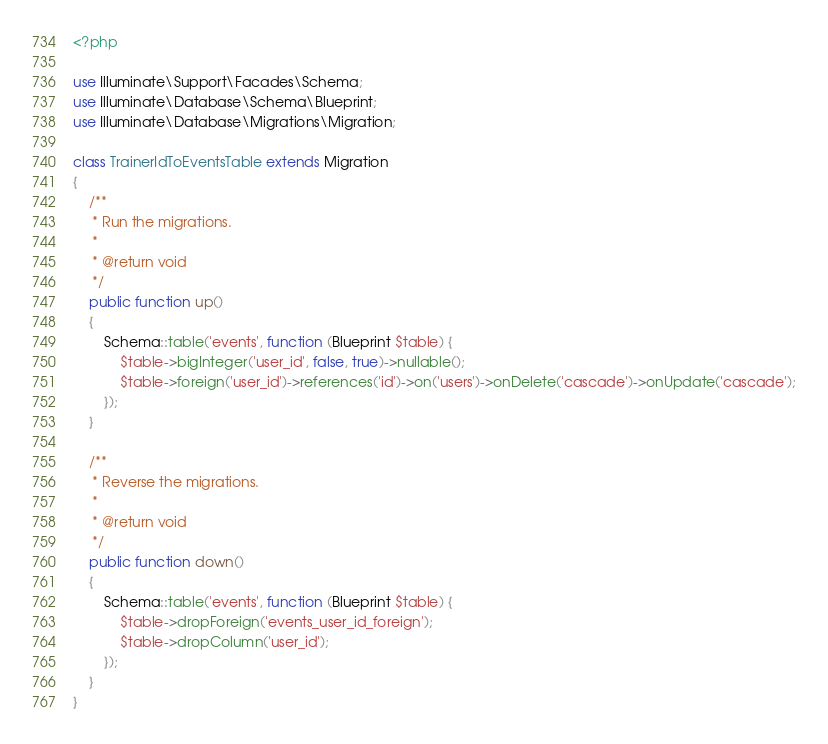Convert code to text. <code><loc_0><loc_0><loc_500><loc_500><_PHP_><?php

use Illuminate\Support\Facades\Schema;
use Illuminate\Database\Schema\Blueprint;
use Illuminate\Database\Migrations\Migration;

class TrainerIdToEventsTable extends Migration
{
    /**
     * Run the migrations.
     *
     * @return void
     */
    public function up()
    {
        Schema::table('events', function (Blueprint $table) {
            $table->bigInteger('user_id', false, true)->nullable();
            $table->foreign('user_id')->references('id')->on('users')->onDelete('cascade')->onUpdate('cascade');
        });
    }

    /**
     * Reverse the migrations.
     *
     * @return void
     */
    public function down()
    {
        Schema::table('events', function (Blueprint $table) {
            $table->dropForeign('events_user_id_foreign');
            $table->dropColumn('user_id');
        });
    }
}
</code> 